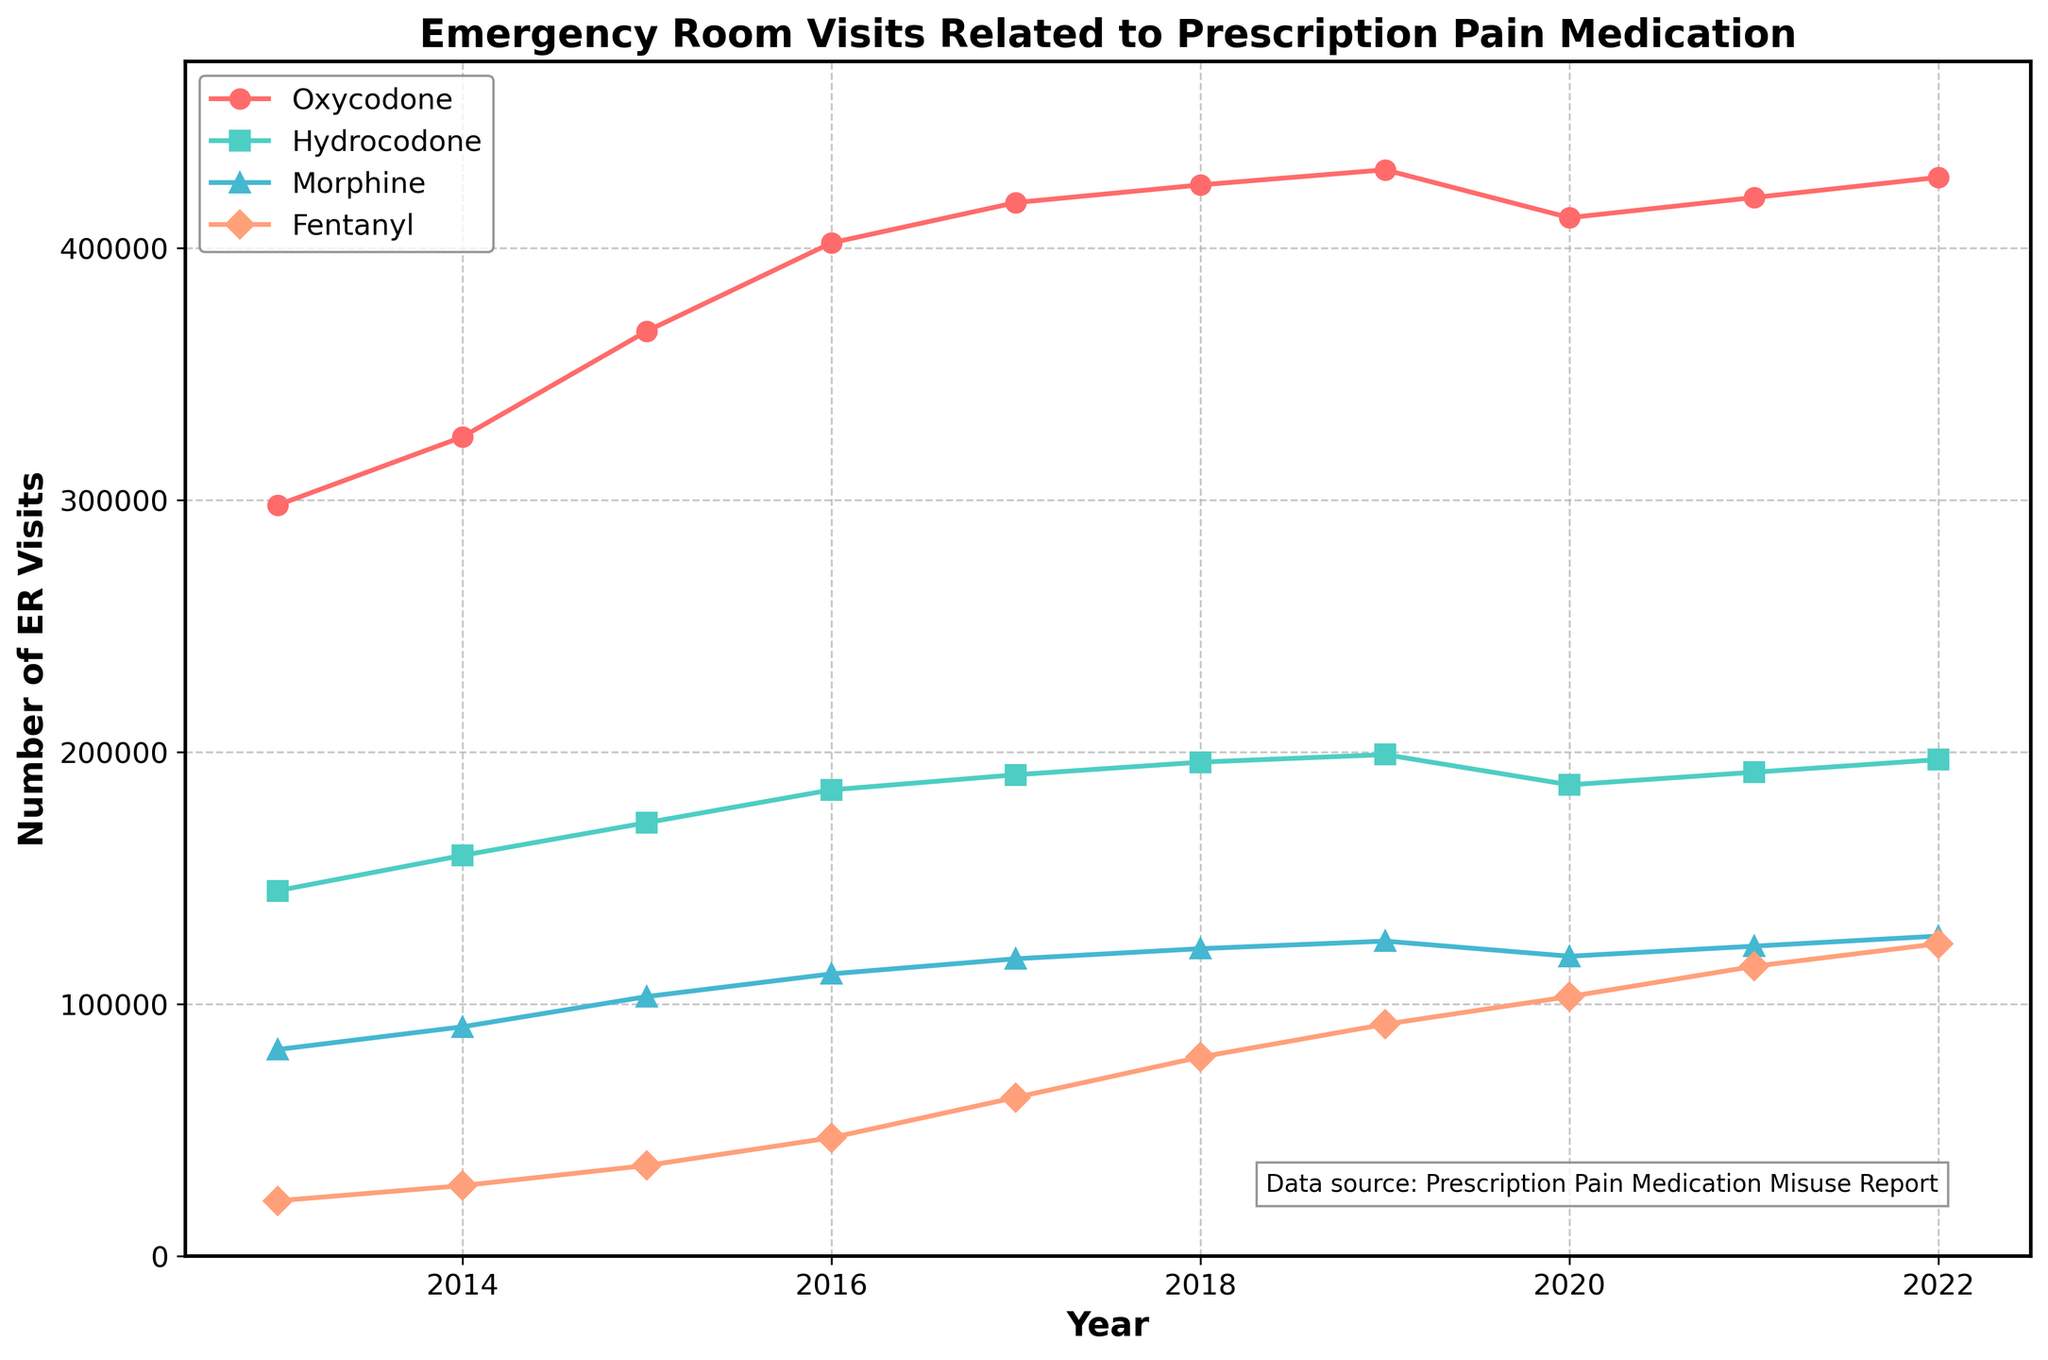What year experienced the highest number of ER visits related to Oxycodone misuse? The highest point on the Oxycodone line indicates the maximum number. Observing the graph, the highest Oxycodone-related visits occur in 2019, with 431,000 visits.
Answer: 2019 Which prescription pain medication saw the largest increase in ER visits from 2013 to 2019? The largest increase can be identified by subtracting the starting value (2013) from the ending value (2019) for each medication. Oxycodone increased from 298,000 to 431,000 (133,000 increase), Hydrocodone from 145,000 to 199,000 (54,000 increase), Morphine from 82,000 to 125,000 (43,000 increase), and Fentanyl from 22,000 to 92,000 (70,000 increase). Oxycodone has the largest increase of 133,000 visits.
Answer: Oxycodone Compare the trend of Fentanyl-related ER visits with that of Morphine between 2015 and 2022. Which one increased more sharply? The trend can be observed by comparing the slope of the lines for the two medications over the years. Fentanyl's trend shows a sharp rise whereas Morphine has a more gradual increase. Fentanyl starts at 36,000 in 2015 and rises to 124,000 in 2022 (88,000 increase), while Morphine starts at 103,000 in 2015 and rises to 127,000 in 2022 (24,000 increase).
Answer: Fentanyl What's the total number of ER visits related to Hydrocodone misuse from 2013 to 2022? Summing up the yearly visits from the Hydrocodone line: 145,000 + 159,000 + 172,000 + 185,000 + 191,000 + 196,000 + 199,000 + 187,000 + 192,000 + 197,000 = 1,723,000
Answer: 1,723,000 How did the total number of ER visits related to prescription pain medication misuse change from 2019 to 2020? Looking at the total number of ER visits in 2019 and 2020: 1,897,000 in 2019 and 1,756,000 in 2020. The difference is 1,897,000 - 1,756,000, which is a decrease of 141,000.
Answer: Decreased Between 2021 and 2022, which drug showed the greatest increase in ER visits? For each drug, the increase is calculated by subtracting the 2021 value from the 2022 value. Oxycodone increased from 420,000 to 428,000 (8,000 increase), Hydrocodone increased from 192,000 to 197,000 (5,000 increase), Morphine increased from 123,000 to 127,000 (4,000 increase), and Fentanyl increased from 115,000 to 124,000 (9,000 increase). The greatest increase is seen in Fentanyl with 9,000.
Answer: Fentanyl 